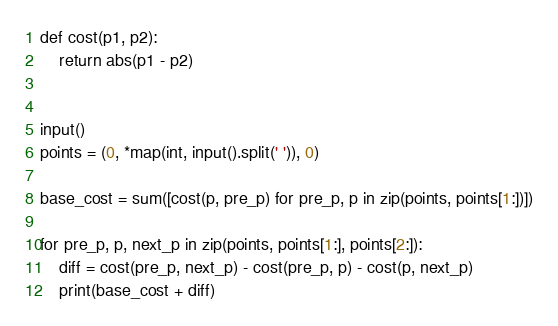Convert code to text. <code><loc_0><loc_0><loc_500><loc_500><_Python_>def cost(p1, p2):
    return abs(p1 - p2)


input()
points = (0, *map(int, input().split(' ')), 0)

base_cost = sum([cost(p, pre_p) for pre_p, p in zip(points, points[1:])])

for pre_p, p, next_p in zip(points, points[1:], points[2:]):
    diff = cost(pre_p, next_p) - cost(pre_p, p) - cost(p, next_p)
    print(base_cost + diff)
</code> 